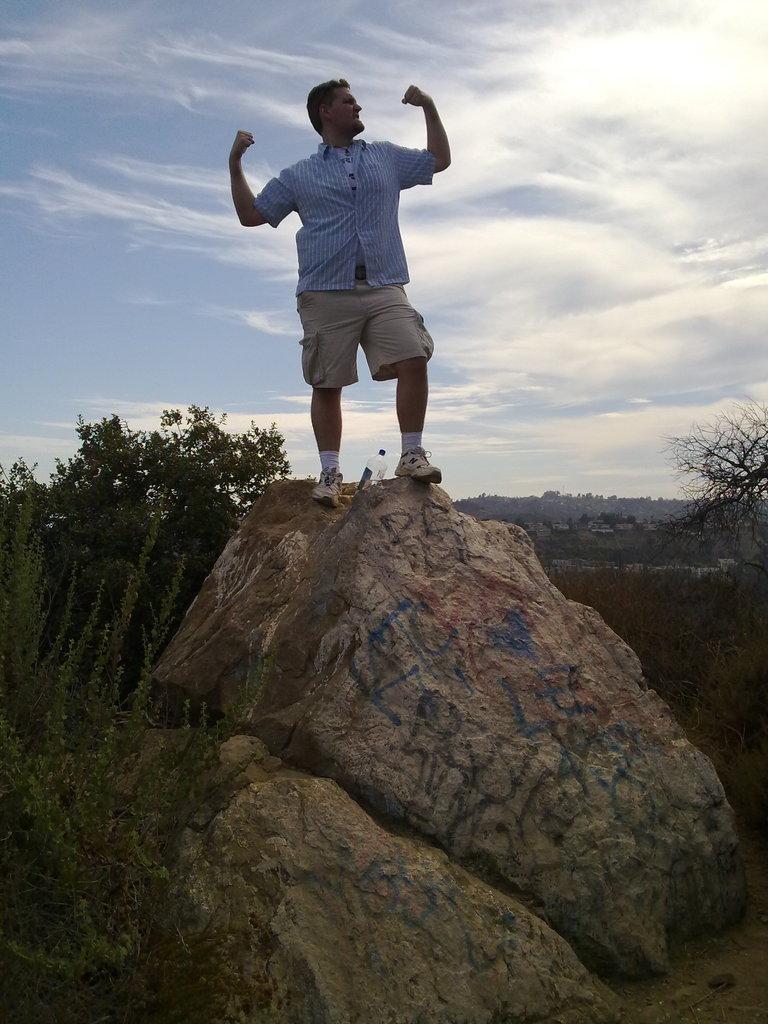In one or two sentences, can you explain what this image depicts? In this image we can see a person is standing on the mountain. Behind trees are there. The sky is in blue color with some clouds. 